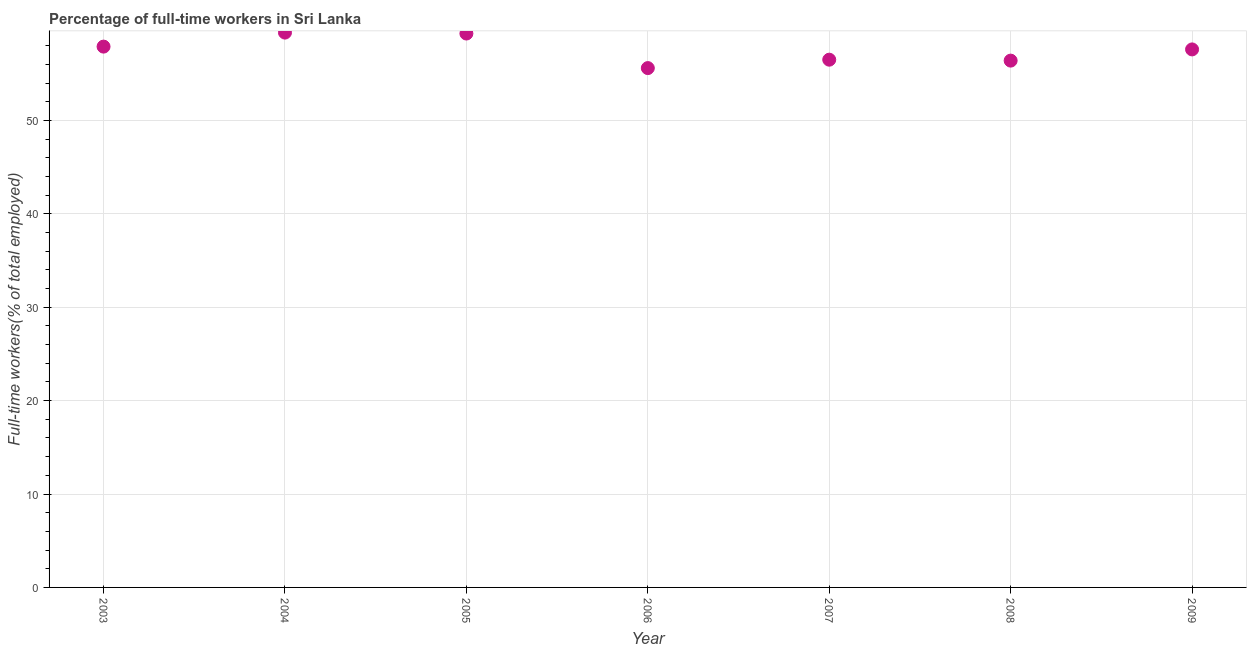What is the percentage of full-time workers in 2008?
Provide a succinct answer. 56.4. Across all years, what is the maximum percentage of full-time workers?
Your answer should be compact. 59.4. Across all years, what is the minimum percentage of full-time workers?
Give a very brief answer. 55.6. In which year was the percentage of full-time workers maximum?
Provide a succinct answer. 2004. What is the sum of the percentage of full-time workers?
Your answer should be very brief. 402.7. What is the difference between the percentage of full-time workers in 2008 and 2009?
Your answer should be very brief. -1.2. What is the average percentage of full-time workers per year?
Offer a very short reply. 57.53. What is the median percentage of full-time workers?
Ensure brevity in your answer.  57.6. Do a majority of the years between 2006 and 2008 (inclusive) have percentage of full-time workers greater than 32 %?
Provide a short and direct response. Yes. What is the ratio of the percentage of full-time workers in 2004 to that in 2006?
Provide a succinct answer. 1.07. What is the difference between the highest and the second highest percentage of full-time workers?
Give a very brief answer. 0.1. What is the difference between the highest and the lowest percentage of full-time workers?
Your response must be concise. 3.8. Does the percentage of full-time workers monotonically increase over the years?
Provide a succinct answer. No. What is the difference between two consecutive major ticks on the Y-axis?
Provide a succinct answer. 10. Are the values on the major ticks of Y-axis written in scientific E-notation?
Your answer should be very brief. No. Does the graph contain any zero values?
Give a very brief answer. No. Does the graph contain grids?
Offer a terse response. Yes. What is the title of the graph?
Offer a terse response. Percentage of full-time workers in Sri Lanka. What is the label or title of the X-axis?
Offer a terse response. Year. What is the label or title of the Y-axis?
Your answer should be very brief. Full-time workers(% of total employed). What is the Full-time workers(% of total employed) in 2003?
Provide a short and direct response. 57.9. What is the Full-time workers(% of total employed) in 2004?
Ensure brevity in your answer.  59.4. What is the Full-time workers(% of total employed) in 2005?
Ensure brevity in your answer.  59.3. What is the Full-time workers(% of total employed) in 2006?
Make the answer very short. 55.6. What is the Full-time workers(% of total employed) in 2007?
Your answer should be compact. 56.5. What is the Full-time workers(% of total employed) in 2008?
Make the answer very short. 56.4. What is the Full-time workers(% of total employed) in 2009?
Give a very brief answer. 57.6. What is the difference between the Full-time workers(% of total employed) in 2003 and 2006?
Your response must be concise. 2.3. What is the difference between the Full-time workers(% of total employed) in 2003 and 2009?
Keep it short and to the point. 0.3. What is the difference between the Full-time workers(% of total employed) in 2004 and 2005?
Keep it short and to the point. 0.1. What is the difference between the Full-time workers(% of total employed) in 2004 and 2006?
Make the answer very short. 3.8. What is the difference between the Full-time workers(% of total employed) in 2004 and 2007?
Offer a very short reply. 2.9. What is the difference between the Full-time workers(% of total employed) in 2004 and 2009?
Keep it short and to the point. 1.8. What is the difference between the Full-time workers(% of total employed) in 2005 and 2008?
Offer a terse response. 2.9. What is the difference between the Full-time workers(% of total employed) in 2005 and 2009?
Offer a very short reply. 1.7. What is the difference between the Full-time workers(% of total employed) in 2008 and 2009?
Ensure brevity in your answer.  -1.2. What is the ratio of the Full-time workers(% of total employed) in 2003 to that in 2006?
Give a very brief answer. 1.04. What is the ratio of the Full-time workers(% of total employed) in 2004 to that in 2005?
Your answer should be very brief. 1. What is the ratio of the Full-time workers(% of total employed) in 2004 to that in 2006?
Provide a succinct answer. 1.07. What is the ratio of the Full-time workers(% of total employed) in 2004 to that in 2007?
Your answer should be very brief. 1.05. What is the ratio of the Full-time workers(% of total employed) in 2004 to that in 2008?
Provide a succinct answer. 1.05. What is the ratio of the Full-time workers(% of total employed) in 2004 to that in 2009?
Provide a short and direct response. 1.03. What is the ratio of the Full-time workers(% of total employed) in 2005 to that in 2006?
Make the answer very short. 1.07. What is the ratio of the Full-time workers(% of total employed) in 2005 to that in 2008?
Your response must be concise. 1.05. What is the ratio of the Full-time workers(% of total employed) in 2005 to that in 2009?
Ensure brevity in your answer.  1.03. What is the ratio of the Full-time workers(% of total employed) in 2006 to that in 2007?
Ensure brevity in your answer.  0.98. What is the ratio of the Full-time workers(% of total employed) in 2006 to that in 2009?
Provide a short and direct response. 0.96. What is the ratio of the Full-time workers(% of total employed) in 2007 to that in 2009?
Provide a succinct answer. 0.98. 